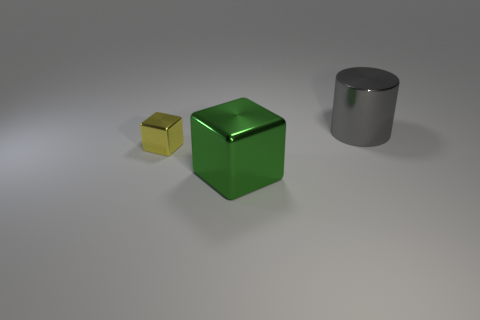What material is the green block?
Keep it short and to the point. Metal. There is a big metallic block; does it have the same color as the object that is behind the tiny metallic object?
Offer a terse response. No. Are there any other things that have the same size as the yellow cube?
Provide a succinct answer. No. What is the size of the thing that is both in front of the gray metallic thing and right of the tiny yellow cube?
Offer a terse response. Large. What shape is the gray object that is made of the same material as the yellow block?
Offer a terse response. Cylinder. Do the small yellow cube and the cube that is to the right of the tiny yellow thing have the same material?
Your answer should be very brief. Yes. There is a metal cube behind the green metal cube; are there any big things behind it?
Provide a succinct answer. Yes. There is a yellow thing that is the same shape as the green thing; what is it made of?
Provide a succinct answer. Metal. There is a big shiny thing right of the green metallic block; how many small blocks are behind it?
Give a very brief answer. 0. Are there any other things of the same color as the large shiny cube?
Your answer should be very brief. No. 